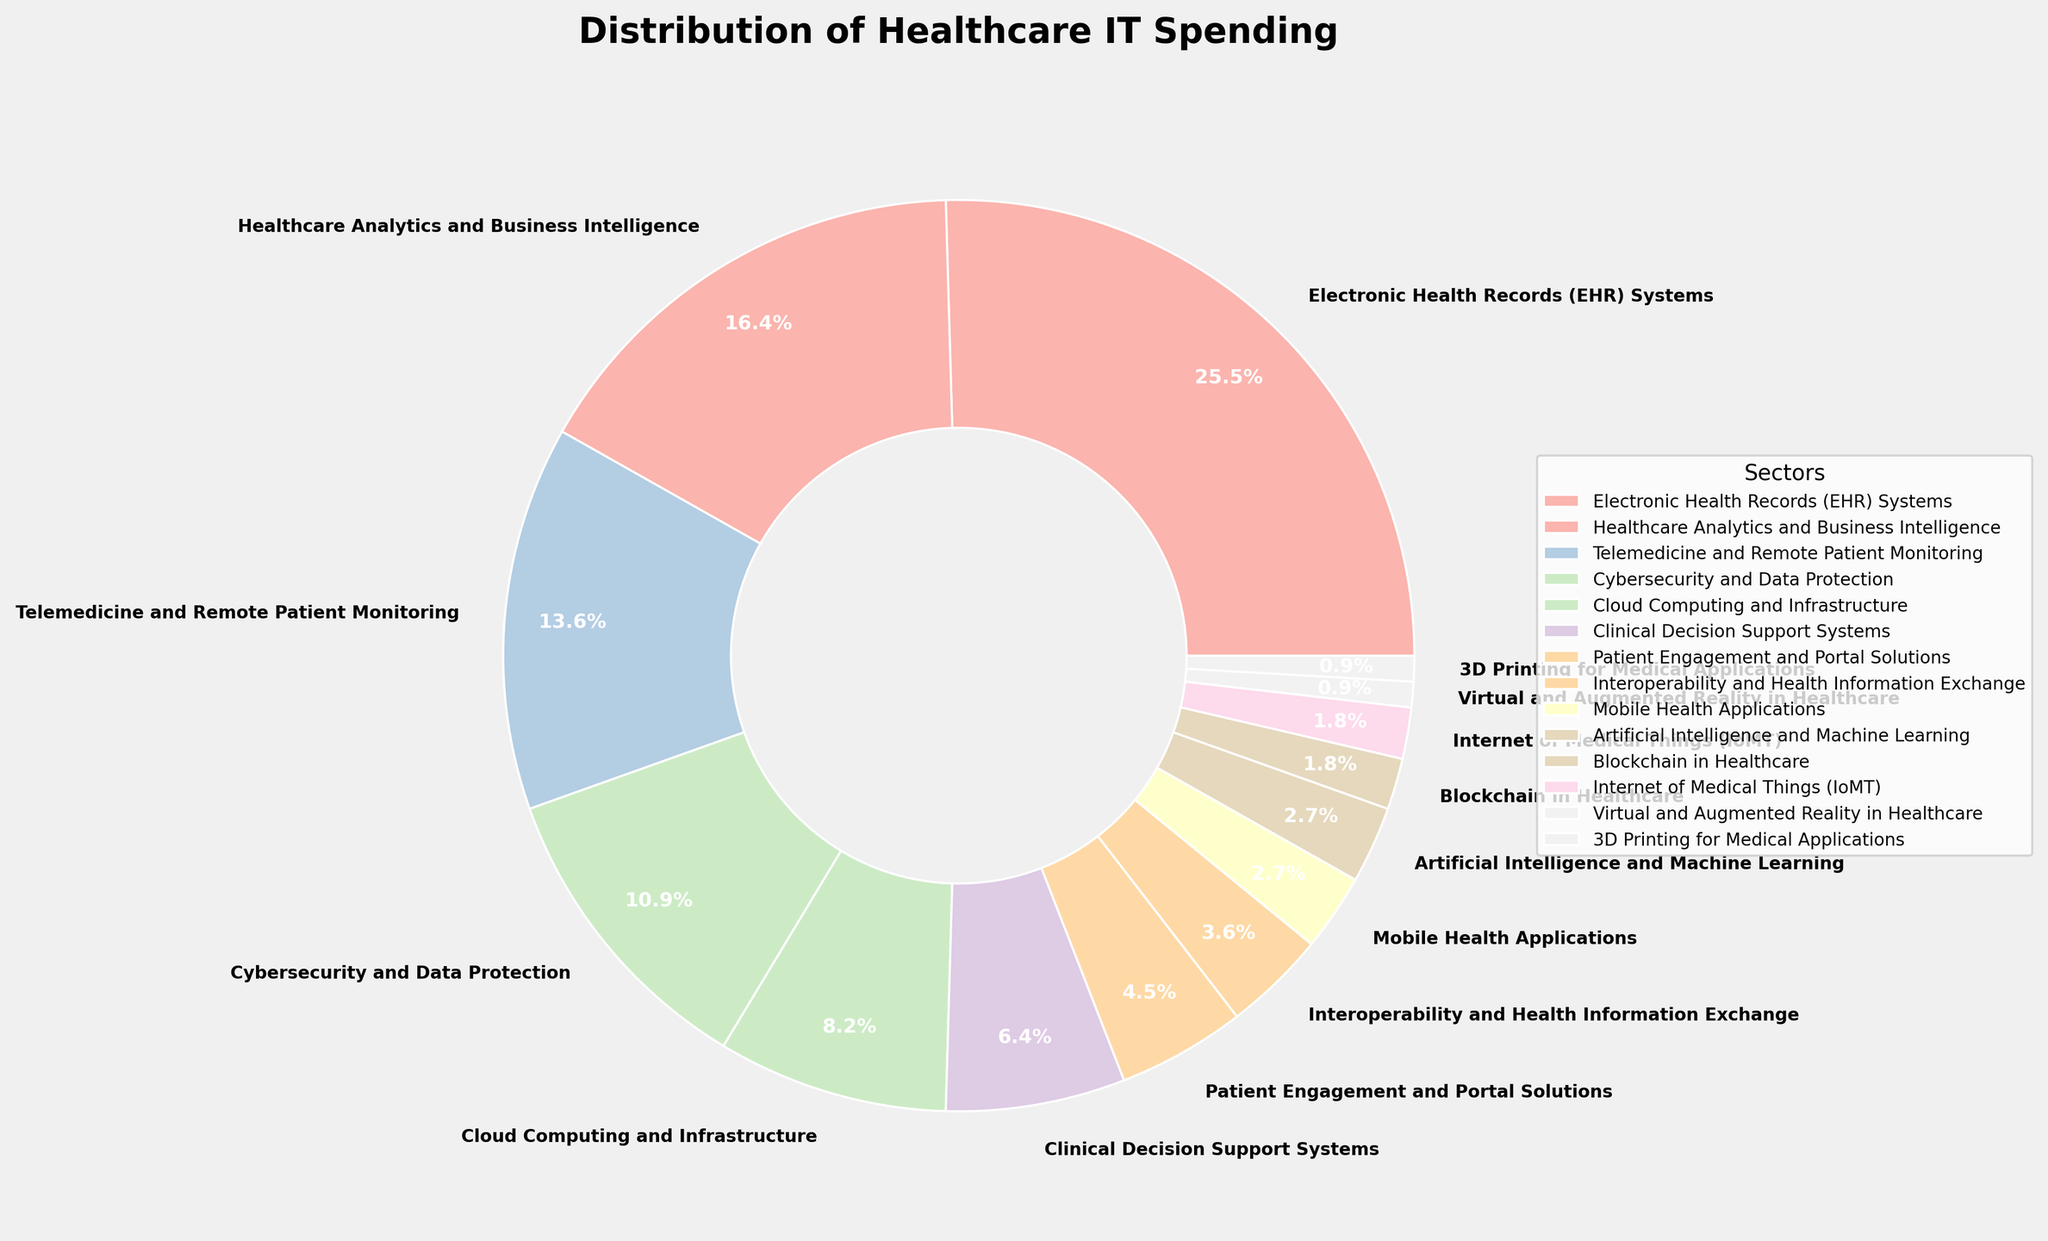What's the largest sector of healthcare IT spending? The largest sector can be identified by looking for the largest segment in the pie chart, which is the one labeled with the highest percentage. The largest segment is labeled with "Electronic Health Records (EHR) Systems" at 28%.
Answer: Electronic Health Records (EHR) Systems Which sector has the smallest percentage of healthcare IT spending? To find the smallest sector, we need to look for the smallest segment in the pie chart. The smallest segments are labeled with "Virtual and Augmented Reality in Healthcare" and "3D Printing for Medical Applications", both at 1%.
Answer: Virtual and Augmented Reality in Healthcare, 3D Printing for Medical Applications How much more is spent on EHR Systems compared to Telemedicine and Remote Patient Monitoring? First, identify the percentages for both sectors from the chart. EHR Systems is 28% and Telemedicine and Remote Patient Monitoring is 15%. The difference is calculated as 28% - 15% = 13%.
Answer: 13% Which sector, Cybersecurity and Data Protection or Mobile Health Applications, has a higher percentage of spending, and by how much? Find the percentages for both sectors: Cybersecurity and Data Protection is 12%, and Mobile Health Applications is 3%. Compare the two by calculating the difference: 12% - 3% = 9%.
Answer: Cybersecurity and Data Protection by 9% What's the combined spending percentage of sectors investing in AI, Blockchain, and Virtual/Augmented Reality? Identify the percentages for each sector: Artificial Intelligence and Machine Learning is 3%, Blockchain in Healthcare is 2%, and Virtual and Augmented Reality in Healthcare is 1%. Sum them up: 3% + 2% + 1% = 6%.
Answer: 6% How does the percentage spent on Cloud Computing and Infrastructure compare to that on Patient Engagement and Portal Solutions? Find the percentages: Cloud Computing and Infrastructure is 9%, and Patient Engagement and Portal Solutions is 5%. Determine which percentage is larger and by how much: 9% - 5% = 4%.
Answer: Cloud Computing and Infrastructure is higher by 4% What is the total percentage of spending on sectors related to data (Cybersecurity, Cloud Computing, and Analytics)? Identify the percentages for each sector: Cybersecurity and Data Protection is 12%, Cloud Computing and Infrastructure is 9%, and Healthcare Analytics and Business Intelligence is 18%. Sum them up: 12% + 9% + 18% = 39%.
Answer: 39% If the spending on EHR Systems were reduced by half, which sector would then have the highest spending? EHR Systems is currently the highest at 28%. Halving it would reduce it to 14%. The next highest percentage after EHR Systems is Healthcare Analytics and Business Intelligence at 18%. Hence, Healthcare Analytics would be the highest.
Answer: Healthcare Analytics and Business Intelligence What's the average percentage of spending for the sectors listed in the pie chart? Calculate the sum of all percentages: 28 + 18 + 15 + 12 + 9 + 7 + 5 + 4 + 3 + 3 + 2 + 2 + 1 + 1 = 110. Divide by the number of sectors (14): 110 / 14 ≈ 7.86%.
Answer: 7.86% What percentage of spending is allocated to sectors with a percentage higher than or equal to 10%? Identify sectors with percentages ≥ 10%: EHR Systems (28%), Healthcare Analytics and Business Intelligence (18%), Telemedicine and Remote Patient Monitoring (15%), and Cybersecurity and Data Protection (12%). Sum them: 28 + 18 + 15 + 12 = 73%.
Answer: 73% 